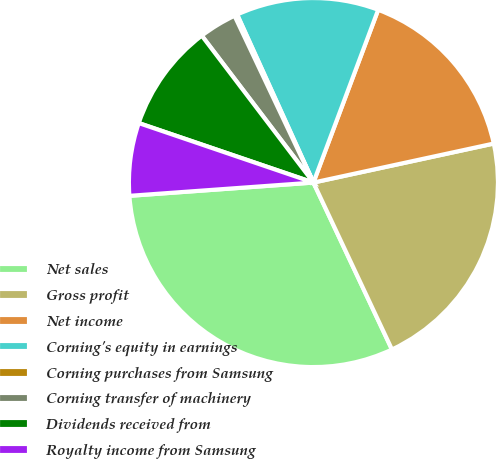Convert chart to OTSL. <chart><loc_0><loc_0><loc_500><loc_500><pie_chart><fcel>Net sales<fcel>Gross profit<fcel>Net income<fcel>Corning's equity in earnings<fcel>Corning purchases from Samsung<fcel>Corning transfer of machinery<fcel>Dividends received from<fcel>Royalty income from Samsung<nl><fcel>30.85%<fcel>21.39%<fcel>15.9%<fcel>12.49%<fcel>0.25%<fcel>3.31%<fcel>9.43%<fcel>6.37%<nl></chart> 